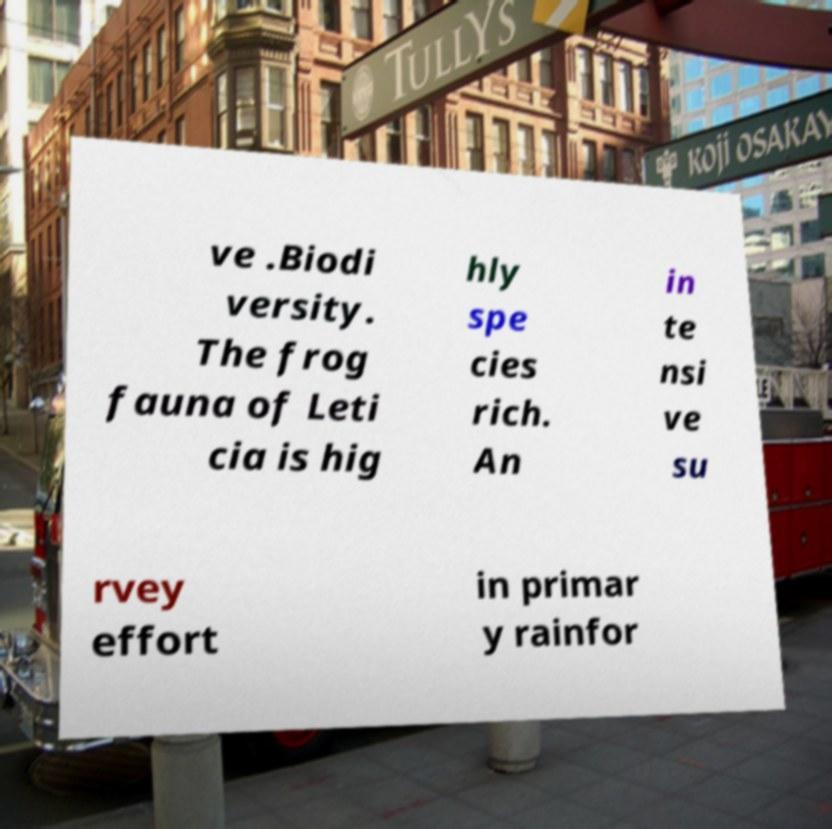There's text embedded in this image that I need extracted. Can you transcribe it verbatim? ve .Biodi versity. The frog fauna of Leti cia is hig hly spe cies rich. An in te nsi ve su rvey effort in primar y rainfor 